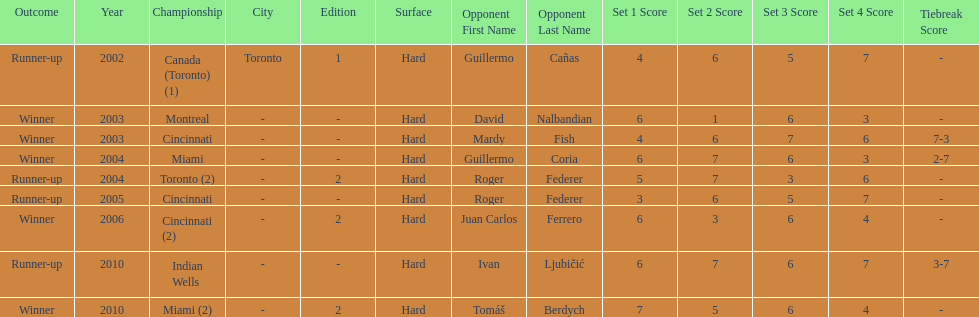How many times were roddick's opponents not from the usa? 8. Could you parse the entire table? {'header': ['Outcome', 'Year', 'Championship', 'City', 'Edition', 'Surface', 'Opponent First Name', 'Opponent Last Name', 'Set 1 Score', 'Set 2 Score', 'Set 3 Score', 'Set 4 Score', 'Tiebreak Score'], 'rows': [['Runner-up', '2002', 'Canada (Toronto) (1)', 'Toronto', '1', 'Hard', 'Guillermo', 'Cañas', '4', '6', '5', '7', '-'], ['Winner', '2003', 'Montreal', '-', '-', 'Hard', 'David', 'Nalbandian', '6', '1', '6', '3', '-'], ['Winner', '2003', 'Cincinnati', '-', '-', 'Hard', 'Mardy', 'Fish', '4', '6', '7', '6', '7-3'], ['Winner', '2004', 'Miami', '-', '-', 'Hard', 'Guillermo', 'Coria', '6', '7', '6', '3', '2-7'], ['Runner-up', '2004', 'Toronto (2)', '-', '2', 'Hard', 'Roger', 'Federer', '5', '7', '3', '6', '-'], ['Runner-up', '2005', 'Cincinnati', '-', '-', 'Hard', 'Roger', 'Federer', '3', '6', '5', '7', '-'], ['Winner', '2006', 'Cincinnati (2)', '-', '2', 'Hard', 'Juan Carlos', 'Ferrero', '6', '3', '6', '4', '-'], ['Runner-up', '2010', 'Indian Wells', '-', '-', 'Hard', 'Ivan', 'Ljubičić', '6', '7', '6', '7', '3-7'], ['Winner', '2010', 'Miami (2)', '-', '2', 'Hard', 'Tomáš', 'Berdych', '7', '5', '6', '4', '-']]} 